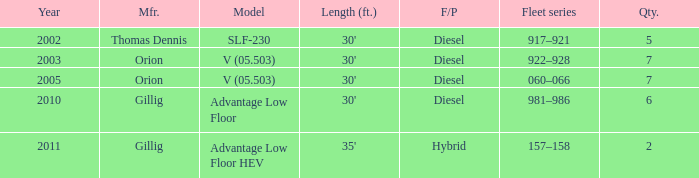Name the sum of quantity for before 2011 model slf-230 5.0. 